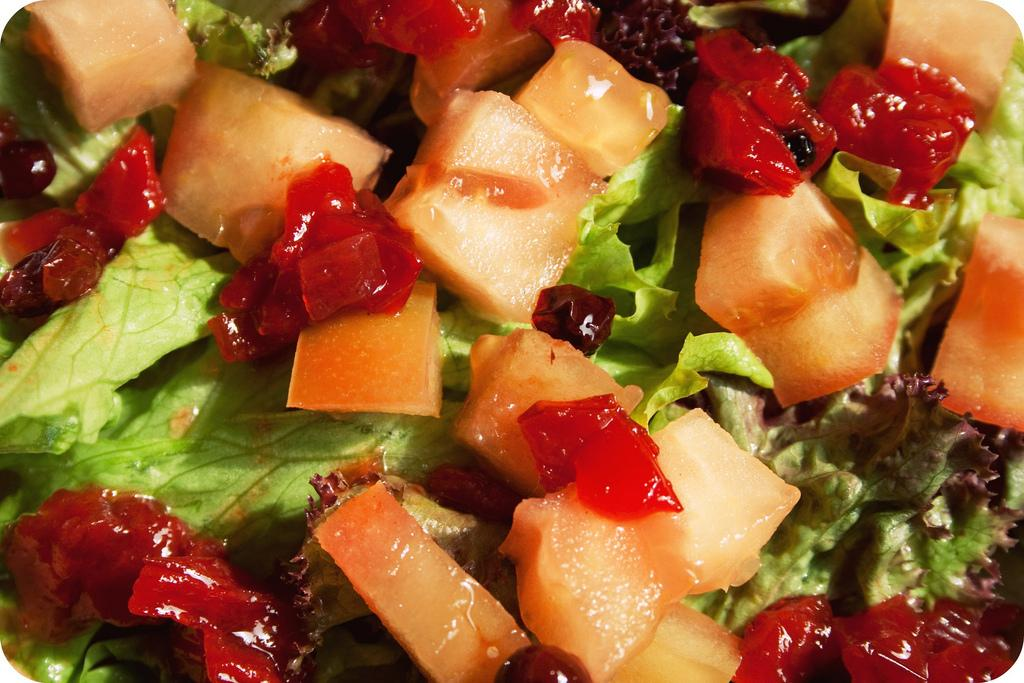What type of fruits and vegetables are present in the image? There are lettuce, raspberries, cherries, and muskmelon in the image. Can you describe the colors of the fruits and vegetables? The raspberries are red, the cherries are red or yellow, and the muskmelon is orange. The lettuce is green. Are there any other types of fruits or vegetables in the image? No, the image only contains lettuce, raspberries, cherries, and muskmelon. What type of sound can be heard coming from the lettuce in the image? There is no sound coming from the lettuce in the image, as fruits and vegetables do not produce sound. 